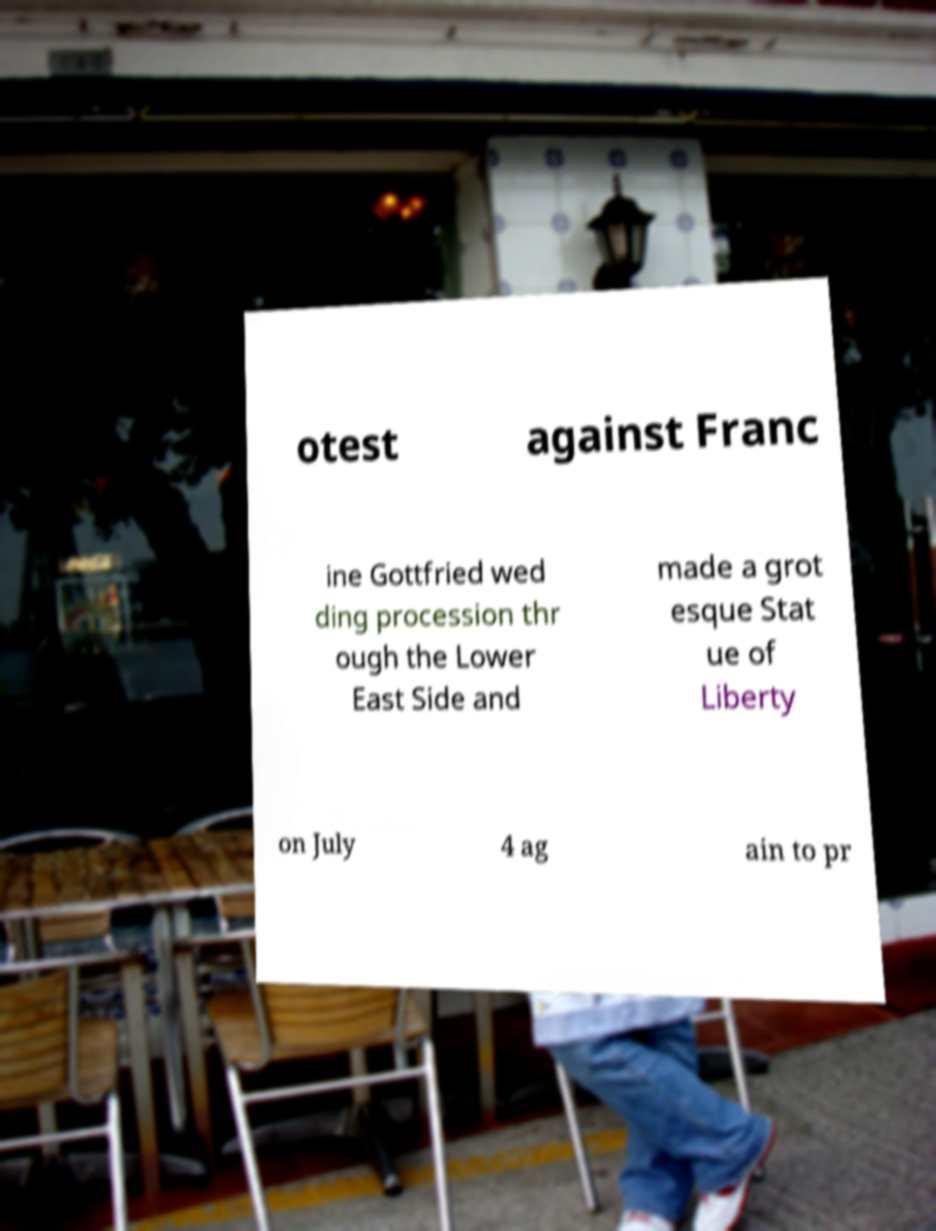There's text embedded in this image that I need extracted. Can you transcribe it verbatim? otest against Franc ine Gottfried wed ding procession thr ough the Lower East Side and made a grot esque Stat ue of Liberty on July 4 ag ain to pr 